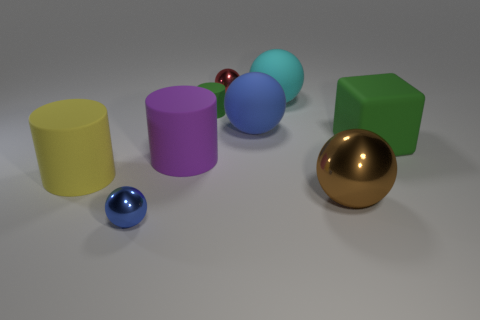The brown sphere that is made of the same material as the tiny blue object is what size?
Your answer should be compact. Large. Are there any other things that are the same color as the large metallic sphere?
Make the answer very short. No. The metal thing that is on the right side of the large blue sphere is what color?
Offer a very short reply. Brown. There is a rubber thing that is to the left of the small metal object that is in front of the small green matte thing; are there any big cyan matte objects in front of it?
Make the answer very short. No. Are there more tiny spheres in front of the large cyan rubber sphere than small red rubber objects?
Ensure brevity in your answer.  Yes. There is a tiny metallic object that is in front of the yellow cylinder; does it have the same shape as the large purple object?
Your answer should be very brief. No. How many things are either big metallic things or rubber objects in front of the tiny green cylinder?
Offer a terse response. 5. There is a matte cylinder that is both behind the big yellow cylinder and in front of the large blue rubber thing; what is its size?
Offer a very short reply. Large. Are there more small things in front of the yellow cylinder than tiny metal objects that are right of the big blue thing?
Provide a succinct answer. Yes. Do the big cyan thing and the tiny shiny object that is behind the blue metallic thing have the same shape?
Ensure brevity in your answer.  Yes. 